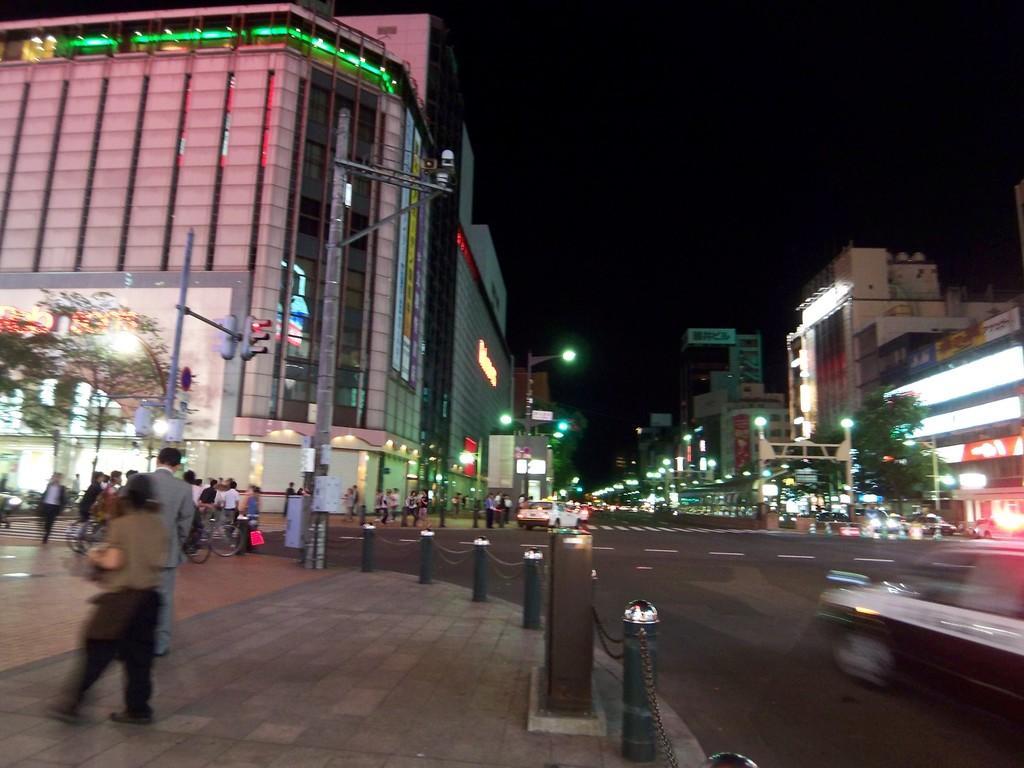Please provide a concise description of this image. In this picture we can see some people are standing, on the right side there is a car, on the left side we can see a tree, in the background there are some buildings, poles, street lights and traffic lights, we can see the sky at the top of the picture. 